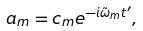Convert formula to latex. <formula><loc_0><loc_0><loc_500><loc_500>a _ { m } = c _ { m } e ^ { - i \tilde { \omega } _ { m } t ^ { \prime } } ,</formula> 